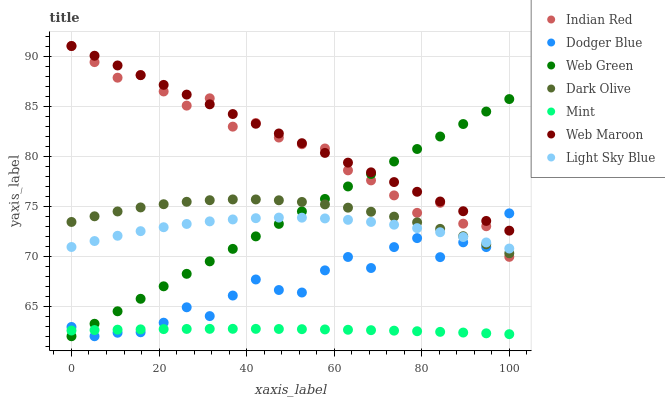Does Mint have the minimum area under the curve?
Answer yes or no. Yes. Does Web Maroon have the maximum area under the curve?
Answer yes or no. Yes. Does Web Green have the minimum area under the curve?
Answer yes or no. No. Does Web Green have the maximum area under the curve?
Answer yes or no. No. Is Web Maroon the smoothest?
Answer yes or no. Yes. Is Dodger Blue the roughest?
Answer yes or no. Yes. Is Web Green the smoothest?
Answer yes or no. No. Is Web Green the roughest?
Answer yes or no. No. Does Web Green have the lowest value?
Answer yes or no. Yes. Does Web Maroon have the lowest value?
Answer yes or no. No. Does Indian Red have the highest value?
Answer yes or no. Yes. Does Web Green have the highest value?
Answer yes or no. No. Is Dark Olive less than Web Maroon?
Answer yes or no. Yes. Is Indian Red greater than Mint?
Answer yes or no. Yes. Does Web Maroon intersect Dodger Blue?
Answer yes or no. Yes. Is Web Maroon less than Dodger Blue?
Answer yes or no. No. Is Web Maroon greater than Dodger Blue?
Answer yes or no. No. Does Dark Olive intersect Web Maroon?
Answer yes or no. No. 